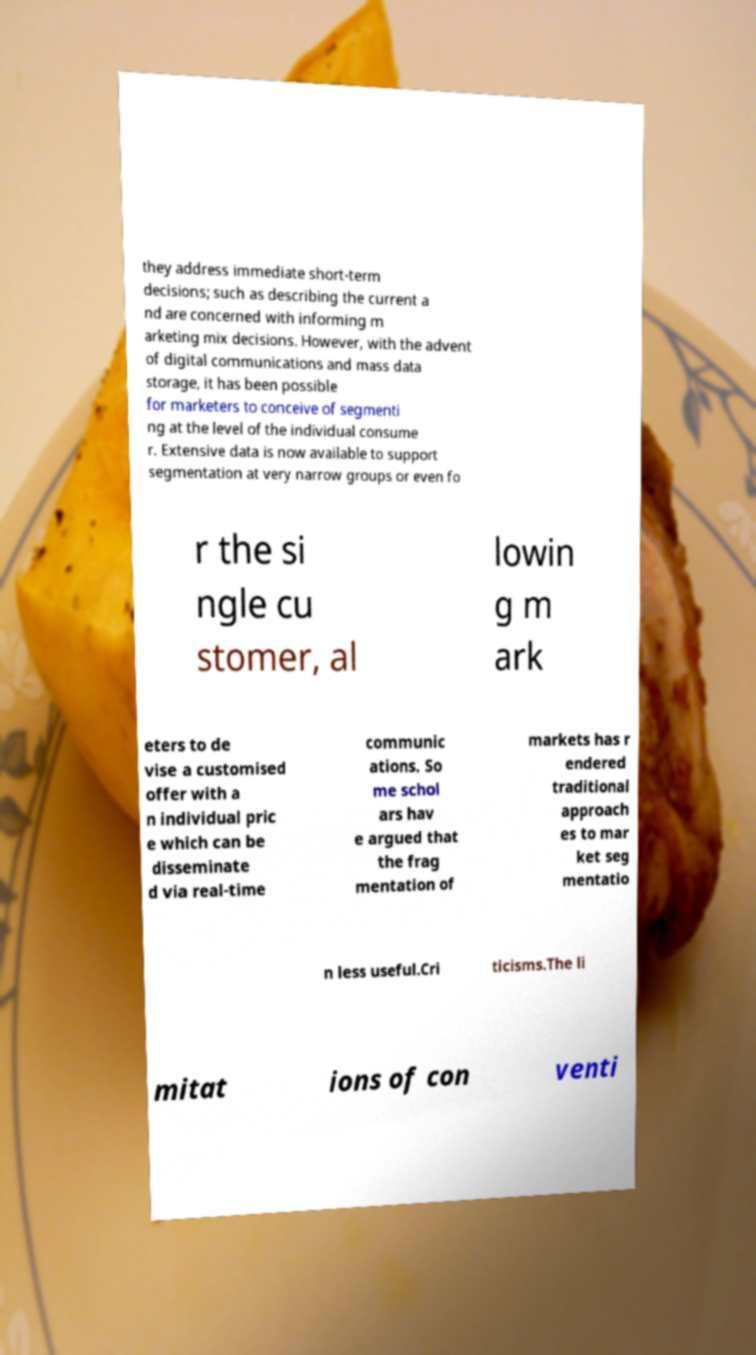Could you extract and type out the text from this image? they address immediate short-term decisions; such as describing the current a nd are concerned with informing m arketing mix decisions. However, with the advent of digital communications and mass data storage, it has been possible for marketers to conceive of segmenti ng at the level of the individual consume r. Extensive data is now available to support segmentation at very narrow groups or even fo r the si ngle cu stomer, al lowin g m ark eters to de vise a customised offer with a n individual pric e which can be disseminate d via real-time communic ations. So me schol ars hav e argued that the frag mentation of markets has r endered traditional approach es to mar ket seg mentatio n less useful.Cri ticisms.The li mitat ions of con venti 